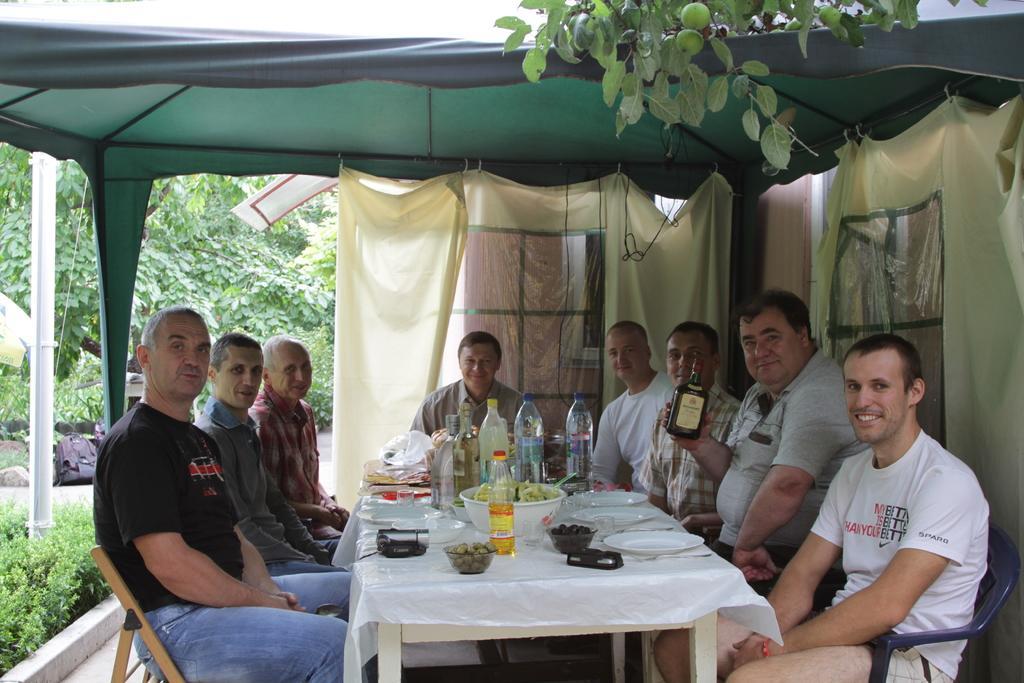How would you summarize this image in a sentence or two? This picture shows a group of people with a smile on their faces and a table on the table We can see water bottles,a bowl and plates. They are seated under a tent and it is surrounded by trees. 